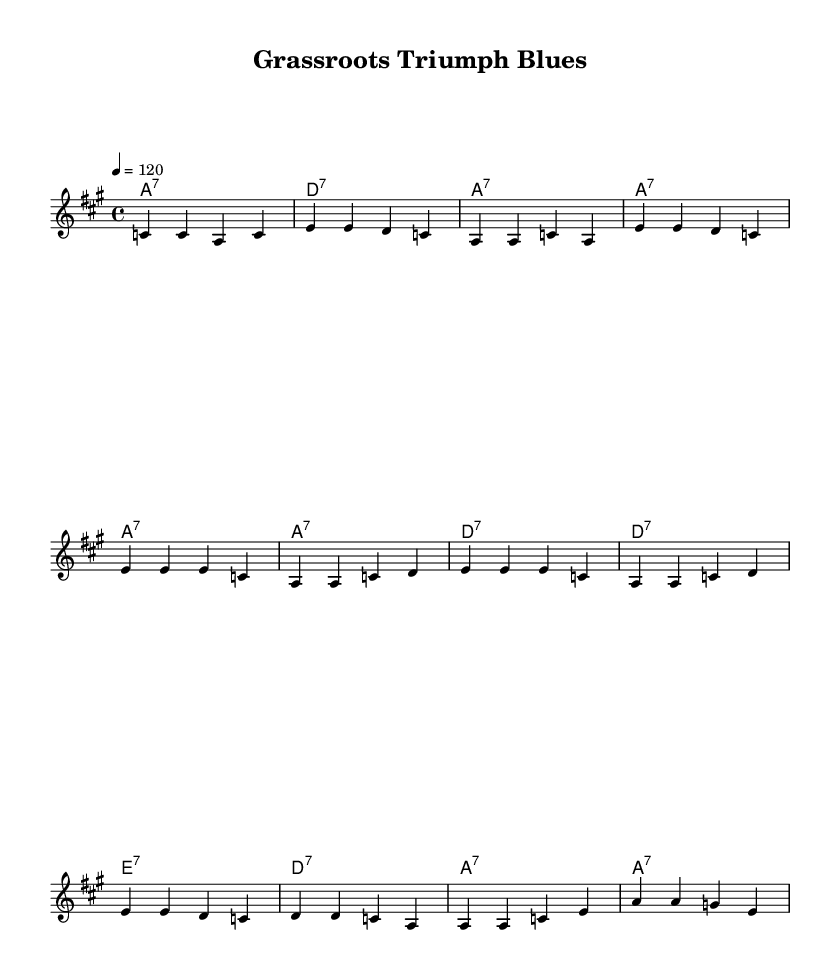What is the key signature of this music? The key signature indicates that the piece is in A major, which has three sharps (F#, C#, and G#). The key is evident in the global section of the score.
Answer: A major What is the time signature of this music? The time signature is found at the beginning of the sheet music, shown as 4/4, which means there are four beats per measure and a quarter note gets one beat.
Answer: 4/4 What is the tempo of the music? The tempo marking, located in the global section, indicates a tempo of 120 beats per minute, guiding the speed of the performance.
Answer: 120 What is the primary chord used in the verse? Looking at the harmonies in the verse section, the predominant chord shown is A seventh (a7), repeated in each measure of the verse.
Answer: A7 How many measures are in the bridge? There are four distinct measures in the bridge section, as counted in the score where the lyrics and chords for the bridge are laid out.
Answer: 4 What is the purpose of this piece in relation to its theme? This piece serves to celebrate grassroots movements and underdog victories in elections, as reflected in the lyrics and overall tone of the music.
Answer: Celebrate underdogs What type of song structure does this piece exhibit? The structure is typical for Blues and is composed of verses followed by a repeating chorus, indicating a standard 12-bar blues format.
Answer: Verse-Chorus 